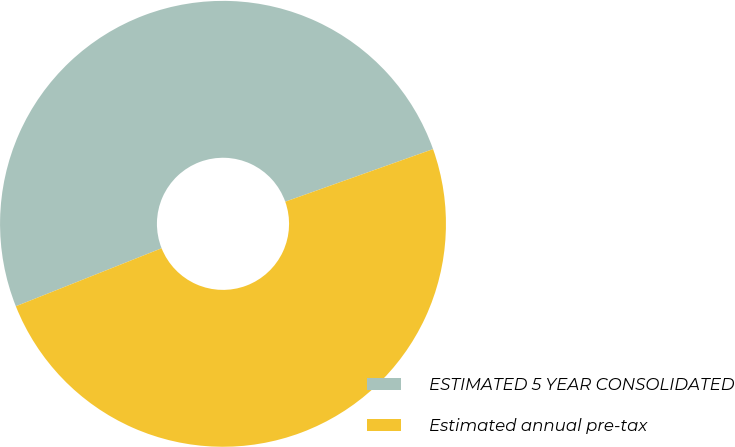Convert chart to OTSL. <chart><loc_0><loc_0><loc_500><loc_500><pie_chart><fcel>ESTIMATED 5 YEAR CONSOLIDATED<fcel>Estimated annual pre-tax<nl><fcel>50.59%<fcel>49.41%<nl></chart> 